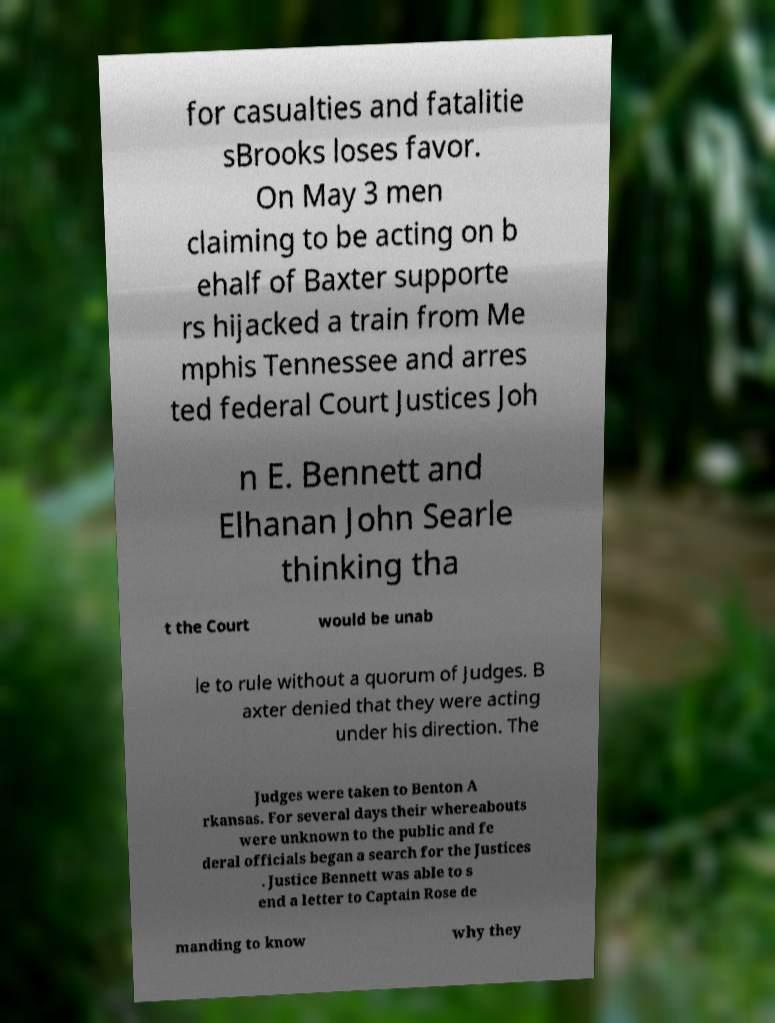What messages or text are displayed in this image? I need them in a readable, typed format. for casualties and fatalitie sBrooks loses favor. On May 3 men claiming to be acting on b ehalf of Baxter supporte rs hijacked a train from Me mphis Tennessee and arres ted federal Court Justices Joh n E. Bennett and Elhanan John Searle thinking tha t the Court would be unab le to rule without a quorum of Judges. B axter denied that they were acting under his direction. The Judges were taken to Benton A rkansas. For several days their whereabouts were unknown to the public and fe deral officials began a search for the Justices . Justice Bennett was able to s end a letter to Captain Rose de manding to know why they 